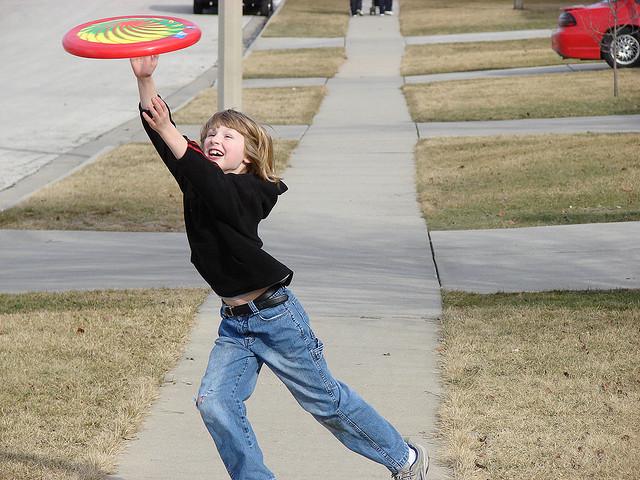What is the boy throwing?
Keep it brief. Frisbee. Is it sunny?
Be succinct. Yes. Where is the child playing?
Keep it brief. Sidewalk. Is the child unhappy?
Short answer required. No. IS the boy happy?
Concise answer only. Yes. Is the kid throwing or catching the frisbee?
Give a very brief answer. Catching. 